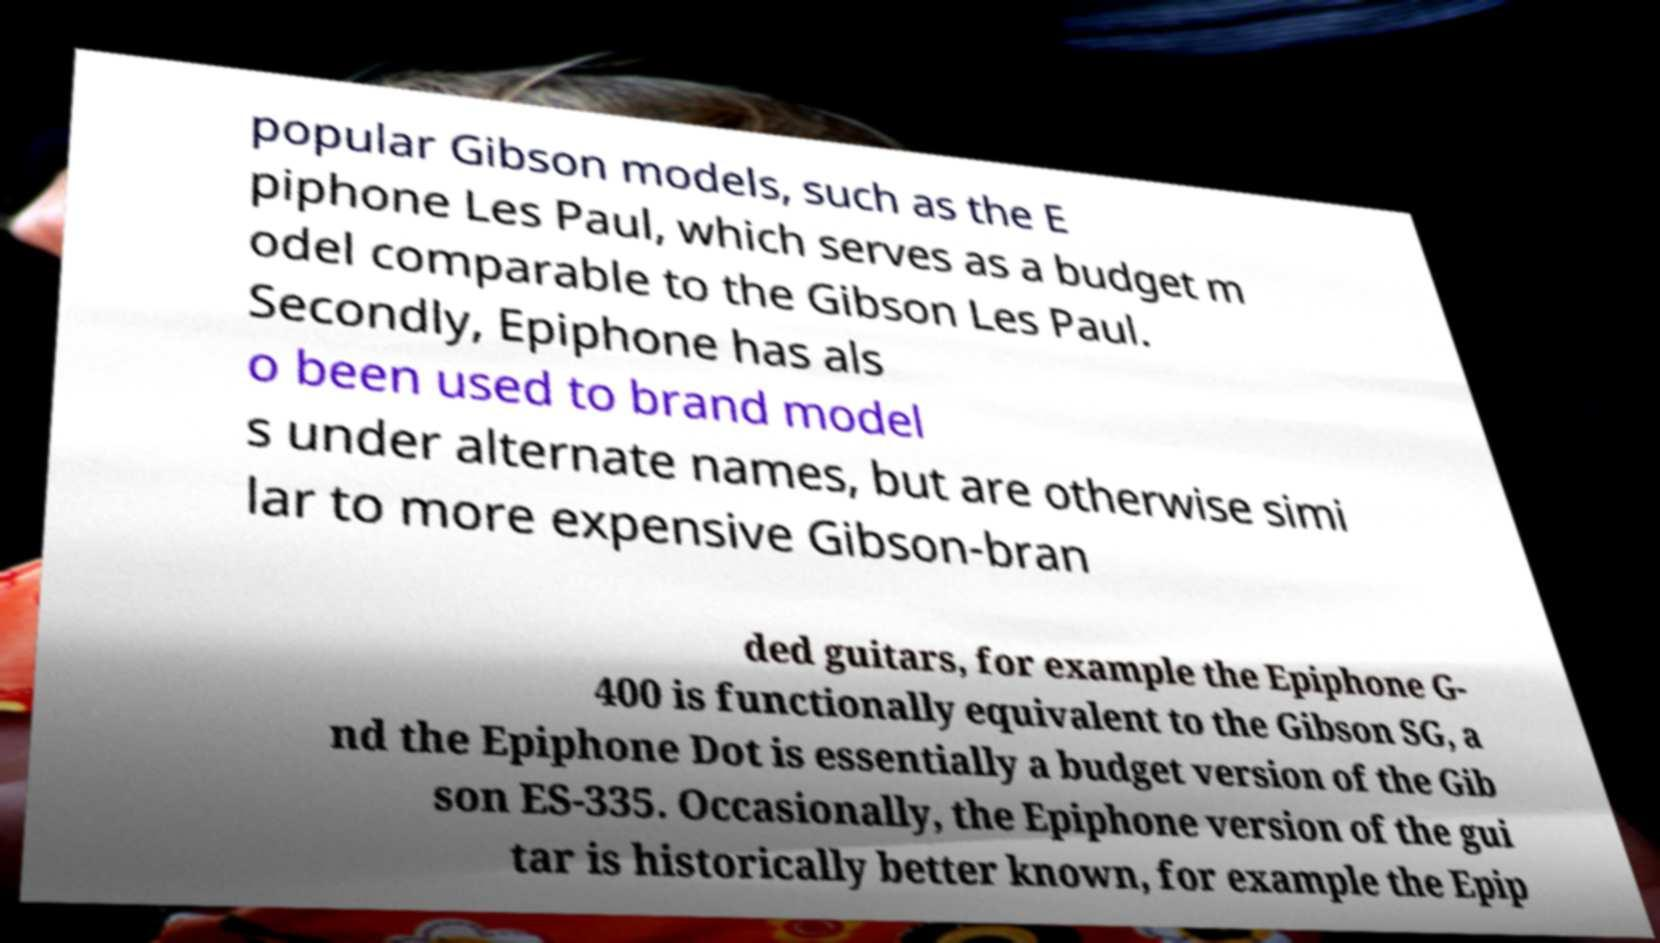There's text embedded in this image that I need extracted. Can you transcribe it verbatim? popular Gibson models, such as the E piphone Les Paul, which serves as a budget m odel comparable to the Gibson Les Paul. Secondly, Epiphone has als o been used to brand model s under alternate names, but are otherwise simi lar to more expensive Gibson-bran ded guitars, for example the Epiphone G- 400 is functionally equivalent to the Gibson SG, a nd the Epiphone Dot is essentially a budget version of the Gib son ES-335. Occasionally, the Epiphone version of the gui tar is historically better known, for example the Epip 